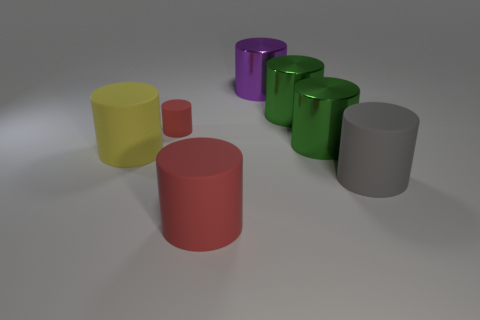Subtract all gray cylinders. How many cylinders are left? 6 Subtract all green metal cylinders. How many cylinders are left? 5 Subtract all red cylinders. Subtract all red blocks. How many cylinders are left? 5 Add 2 tiny red matte things. How many objects exist? 9 Add 1 metallic cylinders. How many metallic cylinders exist? 4 Subtract 0 blue cubes. How many objects are left? 7 Subtract all big cylinders. Subtract all tiny red cylinders. How many objects are left? 0 Add 6 small matte cylinders. How many small matte cylinders are left? 7 